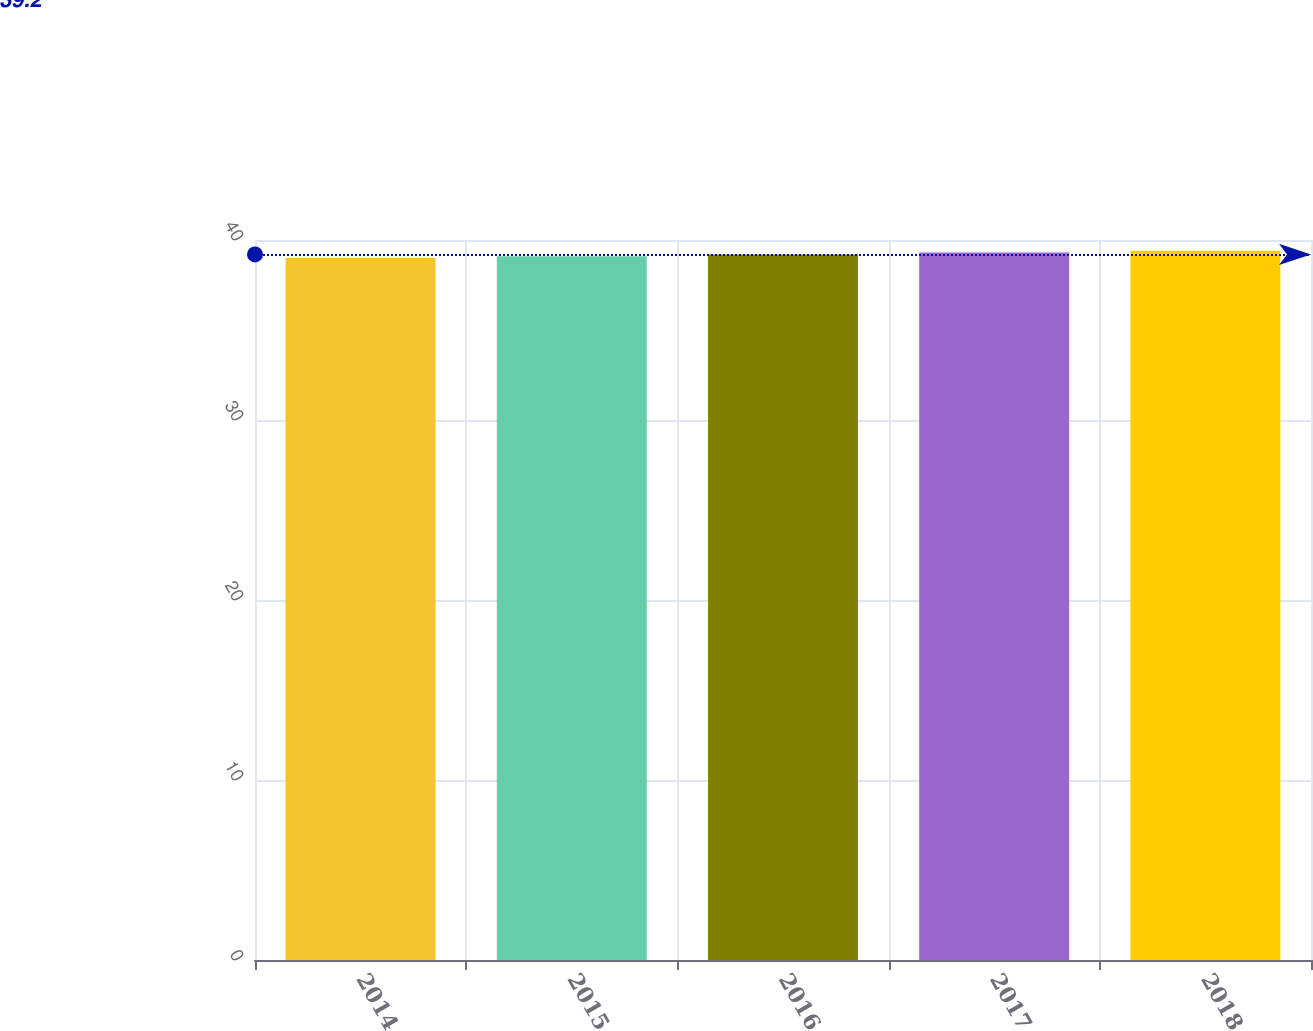Convert chart. <chart><loc_0><loc_0><loc_500><loc_500><bar_chart><fcel>2014<fcel>2015<fcel>2016<fcel>2017<fcel>2018<nl><fcel>39<fcel>39.1<fcel>39.2<fcel>39.3<fcel>39.4<nl></chart> 